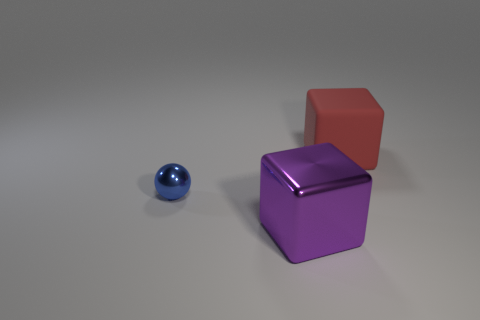What is the size of the metallic thing that is to the left of the large cube that is left of the block behind the tiny blue metallic ball?
Ensure brevity in your answer.  Small. There is a blue object left of the large rubber thing; does it have the same shape as the rubber object?
Your answer should be very brief. No. Is the number of red cubes in front of the large red block less than the number of cubes to the right of the purple thing?
Give a very brief answer. Yes. What material is the big red block?
Keep it short and to the point. Rubber. How many large metal blocks are left of the blue object?
Offer a very short reply. 0. Are there fewer purple cubes on the right side of the purple shiny cube than big rubber blocks?
Offer a very short reply. Yes. The tiny metallic thing has what color?
Give a very brief answer. Blue. There is a large shiny object that is the same shape as the big rubber object; what color is it?
Offer a terse response. Purple. What number of big objects are gray spheres or rubber things?
Keep it short and to the point. 1. There is a block that is behind the large purple metal thing; what is its size?
Provide a short and direct response. Large. 